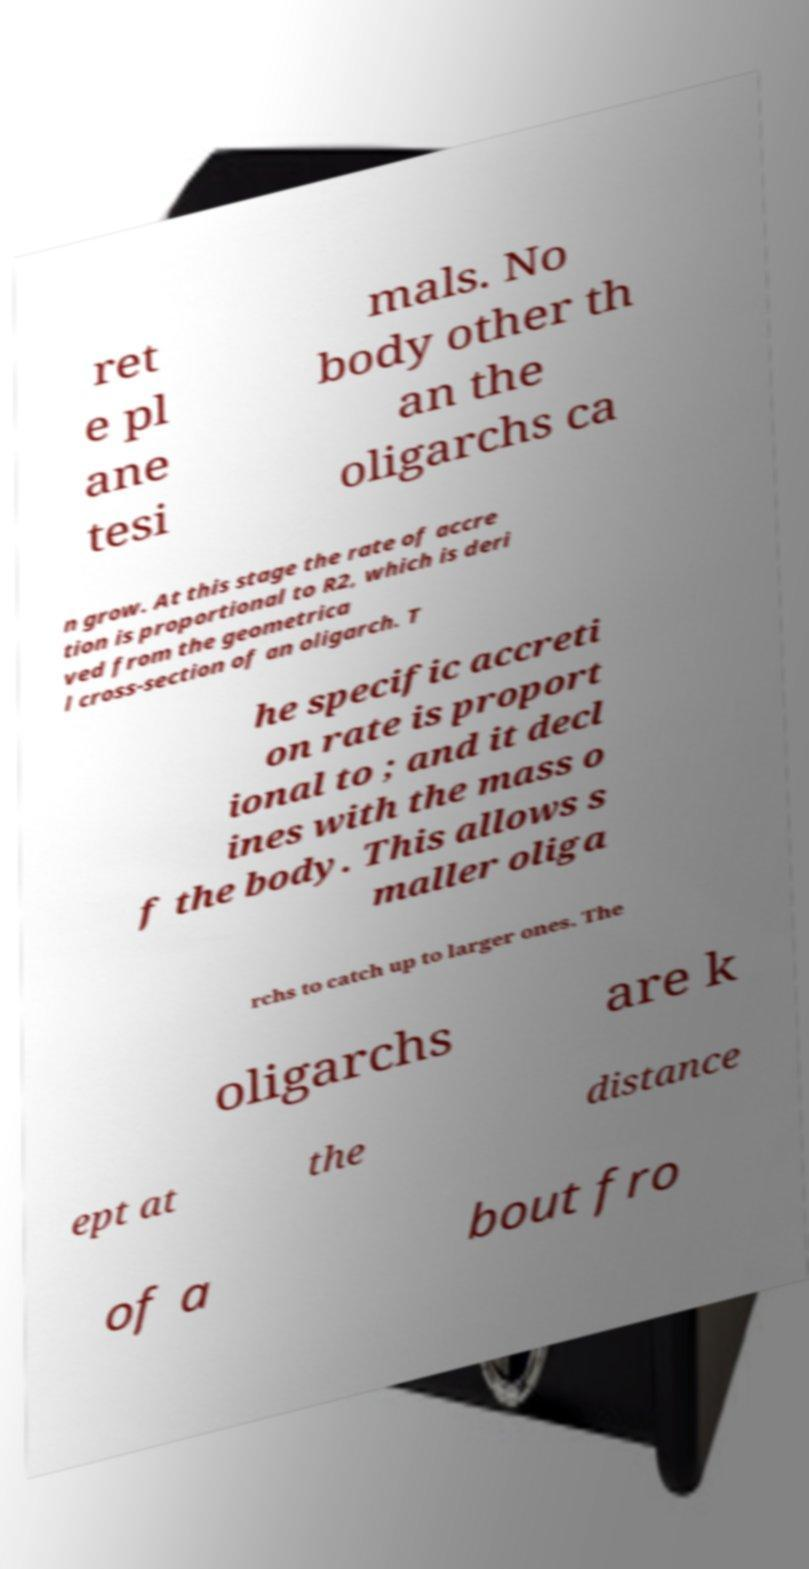Can you accurately transcribe the text from the provided image for me? ret e pl ane tesi mals. No body other th an the oligarchs ca n grow. At this stage the rate of accre tion is proportional to R2, which is deri ved from the geometrica l cross-section of an oligarch. T he specific accreti on rate is proport ional to ; and it decl ines with the mass o f the body. This allows s maller oliga rchs to catch up to larger ones. The oligarchs are k ept at the distance of a bout fro 